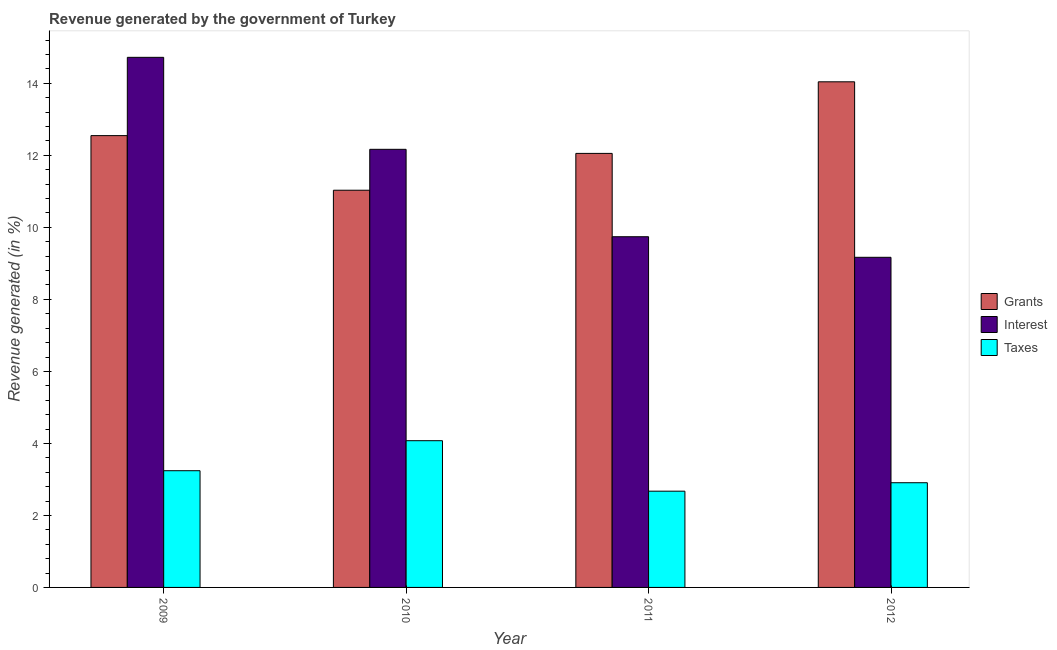How many different coloured bars are there?
Offer a very short reply. 3. How many bars are there on the 1st tick from the right?
Your response must be concise. 3. What is the label of the 3rd group of bars from the left?
Provide a succinct answer. 2011. In how many cases, is the number of bars for a given year not equal to the number of legend labels?
Your answer should be very brief. 0. What is the percentage of revenue generated by taxes in 2009?
Provide a short and direct response. 3.24. Across all years, what is the maximum percentage of revenue generated by interest?
Offer a terse response. 14.72. Across all years, what is the minimum percentage of revenue generated by taxes?
Offer a very short reply. 2.67. In which year was the percentage of revenue generated by interest minimum?
Ensure brevity in your answer.  2012. What is the total percentage of revenue generated by grants in the graph?
Offer a very short reply. 49.68. What is the difference between the percentage of revenue generated by grants in 2009 and that in 2012?
Offer a very short reply. -1.49. What is the difference between the percentage of revenue generated by taxes in 2011 and the percentage of revenue generated by interest in 2009?
Your answer should be very brief. -0.57. What is the average percentage of revenue generated by grants per year?
Your answer should be very brief. 12.42. What is the ratio of the percentage of revenue generated by interest in 2009 to that in 2010?
Provide a succinct answer. 1.21. Is the percentage of revenue generated by interest in 2010 less than that in 2011?
Offer a very short reply. No. What is the difference between the highest and the second highest percentage of revenue generated by grants?
Give a very brief answer. 1.49. What is the difference between the highest and the lowest percentage of revenue generated by grants?
Ensure brevity in your answer.  3.01. In how many years, is the percentage of revenue generated by taxes greater than the average percentage of revenue generated by taxes taken over all years?
Your answer should be very brief. 2. What does the 3rd bar from the left in 2012 represents?
Provide a short and direct response. Taxes. What does the 2nd bar from the right in 2010 represents?
Give a very brief answer. Interest. Is it the case that in every year, the sum of the percentage of revenue generated by grants and percentage of revenue generated by interest is greater than the percentage of revenue generated by taxes?
Offer a terse response. Yes. How many bars are there?
Your answer should be very brief. 12. What is the difference between two consecutive major ticks on the Y-axis?
Give a very brief answer. 2. Does the graph contain grids?
Offer a very short reply. No. Where does the legend appear in the graph?
Offer a very short reply. Center right. How many legend labels are there?
Offer a very short reply. 3. What is the title of the graph?
Make the answer very short. Revenue generated by the government of Turkey. Does "Unemployment benefits" appear as one of the legend labels in the graph?
Provide a short and direct response. No. What is the label or title of the Y-axis?
Keep it short and to the point. Revenue generated (in %). What is the Revenue generated (in %) in Grants in 2009?
Make the answer very short. 12.55. What is the Revenue generated (in %) in Interest in 2009?
Offer a very short reply. 14.72. What is the Revenue generated (in %) of Taxes in 2009?
Offer a very short reply. 3.24. What is the Revenue generated (in %) of Grants in 2010?
Make the answer very short. 11.03. What is the Revenue generated (in %) in Interest in 2010?
Provide a short and direct response. 12.17. What is the Revenue generated (in %) in Taxes in 2010?
Your answer should be very brief. 4.08. What is the Revenue generated (in %) in Grants in 2011?
Ensure brevity in your answer.  12.05. What is the Revenue generated (in %) of Interest in 2011?
Keep it short and to the point. 9.74. What is the Revenue generated (in %) in Taxes in 2011?
Provide a short and direct response. 2.67. What is the Revenue generated (in %) of Grants in 2012?
Offer a very short reply. 14.04. What is the Revenue generated (in %) of Interest in 2012?
Provide a short and direct response. 9.17. What is the Revenue generated (in %) of Taxes in 2012?
Offer a terse response. 2.91. Across all years, what is the maximum Revenue generated (in %) in Grants?
Keep it short and to the point. 14.04. Across all years, what is the maximum Revenue generated (in %) in Interest?
Provide a short and direct response. 14.72. Across all years, what is the maximum Revenue generated (in %) of Taxes?
Provide a succinct answer. 4.08. Across all years, what is the minimum Revenue generated (in %) of Grants?
Provide a succinct answer. 11.03. Across all years, what is the minimum Revenue generated (in %) of Interest?
Give a very brief answer. 9.17. Across all years, what is the minimum Revenue generated (in %) in Taxes?
Your answer should be very brief. 2.67. What is the total Revenue generated (in %) of Grants in the graph?
Ensure brevity in your answer.  49.68. What is the total Revenue generated (in %) of Interest in the graph?
Give a very brief answer. 45.8. What is the total Revenue generated (in %) in Taxes in the graph?
Provide a succinct answer. 12.9. What is the difference between the Revenue generated (in %) in Grants in 2009 and that in 2010?
Make the answer very short. 1.52. What is the difference between the Revenue generated (in %) of Interest in 2009 and that in 2010?
Offer a very short reply. 2.56. What is the difference between the Revenue generated (in %) of Taxes in 2009 and that in 2010?
Ensure brevity in your answer.  -0.83. What is the difference between the Revenue generated (in %) of Grants in 2009 and that in 2011?
Ensure brevity in your answer.  0.49. What is the difference between the Revenue generated (in %) of Interest in 2009 and that in 2011?
Offer a terse response. 4.98. What is the difference between the Revenue generated (in %) of Taxes in 2009 and that in 2011?
Keep it short and to the point. 0.57. What is the difference between the Revenue generated (in %) of Grants in 2009 and that in 2012?
Your answer should be very brief. -1.49. What is the difference between the Revenue generated (in %) of Interest in 2009 and that in 2012?
Provide a succinct answer. 5.55. What is the difference between the Revenue generated (in %) in Taxes in 2009 and that in 2012?
Ensure brevity in your answer.  0.33. What is the difference between the Revenue generated (in %) of Grants in 2010 and that in 2011?
Your answer should be compact. -1.02. What is the difference between the Revenue generated (in %) of Interest in 2010 and that in 2011?
Keep it short and to the point. 2.43. What is the difference between the Revenue generated (in %) of Taxes in 2010 and that in 2011?
Offer a very short reply. 1.4. What is the difference between the Revenue generated (in %) in Grants in 2010 and that in 2012?
Your response must be concise. -3.01. What is the difference between the Revenue generated (in %) in Interest in 2010 and that in 2012?
Offer a very short reply. 3. What is the difference between the Revenue generated (in %) of Taxes in 2010 and that in 2012?
Keep it short and to the point. 1.17. What is the difference between the Revenue generated (in %) of Grants in 2011 and that in 2012?
Offer a terse response. -1.99. What is the difference between the Revenue generated (in %) of Interest in 2011 and that in 2012?
Your answer should be compact. 0.57. What is the difference between the Revenue generated (in %) of Taxes in 2011 and that in 2012?
Keep it short and to the point. -0.23. What is the difference between the Revenue generated (in %) of Grants in 2009 and the Revenue generated (in %) of Interest in 2010?
Your answer should be very brief. 0.38. What is the difference between the Revenue generated (in %) in Grants in 2009 and the Revenue generated (in %) in Taxes in 2010?
Offer a very short reply. 8.47. What is the difference between the Revenue generated (in %) in Interest in 2009 and the Revenue generated (in %) in Taxes in 2010?
Offer a very short reply. 10.65. What is the difference between the Revenue generated (in %) of Grants in 2009 and the Revenue generated (in %) of Interest in 2011?
Keep it short and to the point. 2.81. What is the difference between the Revenue generated (in %) of Grants in 2009 and the Revenue generated (in %) of Taxes in 2011?
Ensure brevity in your answer.  9.88. What is the difference between the Revenue generated (in %) in Interest in 2009 and the Revenue generated (in %) in Taxes in 2011?
Your answer should be compact. 12.05. What is the difference between the Revenue generated (in %) in Grants in 2009 and the Revenue generated (in %) in Interest in 2012?
Ensure brevity in your answer.  3.38. What is the difference between the Revenue generated (in %) in Grants in 2009 and the Revenue generated (in %) in Taxes in 2012?
Provide a succinct answer. 9.64. What is the difference between the Revenue generated (in %) of Interest in 2009 and the Revenue generated (in %) of Taxes in 2012?
Your response must be concise. 11.82. What is the difference between the Revenue generated (in %) in Grants in 2010 and the Revenue generated (in %) in Interest in 2011?
Give a very brief answer. 1.29. What is the difference between the Revenue generated (in %) of Grants in 2010 and the Revenue generated (in %) of Taxes in 2011?
Keep it short and to the point. 8.36. What is the difference between the Revenue generated (in %) in Interest in 2010 and the Revenue generated (in %) in Taxes in 2011?
Offer a terse response. 9.5. What is the difference between the Revenue generated (in %) of Grants in 2010 and the Revenue generated (in %) of Interest in 2012?
Offer a very short reply. 1.86. What is the difference between the Revenue generated (in %) of Grants in 2010 and the Revenue generated (in %) of Taxes in 2012?
Your answer should be compact. 8.12. What is the difference between the Revenue generated (in %) of Interest in 2010 and the Revenue generated (in %) of Taxes in 2012?
Your answer should be very brief. 9.26. What is the difference between the Revenue generated (in %) in Grants in 2011 and the Revenue generated (in %) in Interest in 2012?
Provide a succinct answer. 2.89. What is the difference between the Revenue generated (in %) of Grants in 2011 and the Revenue generated (in %) of Taxes in 2012?
Offer a very short reply. 9.15. What is the difference between the Revenue generated (in %) in Interest in 2011 and the Revenue generated (in %) in Taxes in 2012?
Ensure brevity in your answer.  6.83. What is the average Revenue generated (in %) of Grants per year?
Give a very brief answer. 12.42. What is the average Revenue generated (in %) in Interest per year?
Offer a very short reply. 11.45. What is the average Revenue generated (in %) in Taxes per year?
Make the answer very short. 3.22. In the year 2009, what is the difference between the Revenue generated (in %) in Grants and Revenue generated (in %) in Interest?
Give a very brief answer. -2.17. In the year 2009, what is the difference between the Revenue generated (in %) of Grants and Revenue generated (in %) of Taxes?
Make the answer very short. 9.31. In the year 2009, what is the difference between the Revenue generated (in %) of Interest and Revenue generated (in %) of Taxes?
Offer a very short reply. 11.48. In the year 2010, what is the difference between the Revenue generated (in %) in Grants and Revenue generated (in %) in Interest?
Provide a succinct answer. -1.14. In the year 2010, what is the difference between the Revenue generated (in %) in Grants and Revenue generated (in %) in Taxes?
Provide a short and direct response. 6.96. In the year 2010, what is the difference between the Revenue generated (in %) of Interest and Revenue generated (in %) of Taxes?
Keep it short and to the point. 8.09. In the year 2011, what is the difference between the Revenue generated (in %) in Grants and Revenue generated (in %) in Interest?
Keep it short and to the point. 2.31. In the year 2011, what is the difference between the Revenue generated (in %) in Grants and Revenue generated (in %) in Taxes?
Keep it short and to the point. 9.38. In the year 2011, what is the difference between the Revenue generated (in %) in Interest and Revenue generated (in %) in Taxes?
Provide a short and direct response. 7.07. In the year 2012, what is the difference between the Revenue generated (in %) in Grants and Revenue generated (in %) in Interest?
Give a very brief answer. 4.87. In the year 2012, what is the difference between the Revenue generated (in %) of Grants and Revenue generated (in %) of Taxes?
Offer a very short reply. 11.14. In the year 2012, what is the difference between the Revenue generated (in %) in Interest and Revenue generated (in %) in Taxes?
Keep it short and to the point. 6.26. What is the ratio of the Revenue generated (in %) in Grants in 2009 to that in 2010?
Your answer should be compact. 1.14. What is the ratio of the Revenue generated (in %) of Interest in 2009 to that in 2010?
Make the answer very short. 1.21. What is the ratio of the Revenue generated (in %) of Taxes in 2009 to that in 2010?
Keep it short and to the point. 0.8. What is the ratio of the Revenue generated (in %) of Grants in 2009 to that in 2011?
Keep it short and to the point. 1.04. What is the ratio of the Revenue generated (in %) of Interest in 2009 to that in 2011?
Provide a short and direct response. 1.51. What is the ratio of the Revenue generated (in %) of Taxes in 2009 to that in 2011?
Keep it short and to the point. 1.21. What is the ratio of the Revenue generated (in %) of Grants in 2009 to that in 2012?
Offer a terse response. 0.89. What is the ratio of the Revenue generated (in %) in Interest in 2009 to that in 2012?
Your answer should be very brief. 1.61. What is the ratio of the Revenue generated (in %) of Taxes in 2009 to that in 2012?
Give a very brief answer. 1.11. What is the ratio of the Revenue generated (in %) in Grants in 2010 to that in 2011?
Provide a short and direct response. 0.92. What is the ratio of the Revenue generated (in %) in Interest in 2010 to that in 2011?
Give a very brief answer. 1.25. What is the ratio of the Revenue generated (in %) of Taxes in 2010 to that in 2011?
Provide a short and direct response. 1.52. What is the ratio of the Revenue generated (in %) in Grants in 2010 to that in 2012?
Your response must be concise. 0.79. What is the ratio of the Revenue generated (in %) of Interest in 2010 to that in 2012?
Offer a very short reply. 1.33. What is the ratio of the Revenue generated (in %) in Taxes in 2010 to that in 2012?
Offer a terse response. 1.4. What is the ratio of the Revenue generated (in %) of Grants in 2011 to that in 2012?
Provide a short and direct response. 0.86. What is the ratio of the Revenue generated (in %) of Interest in 2011 to that in 2012?
Ensure brevity in your answer.  1.06. What is the ratio of the Revenue generated (in %) in Taxes in 2011 to that in 2012?
Make the answer very short. 0.92. What is the difference between the highest and the second highest Revenue generated (in %) of Grants?
Your answer should be very brief. 1.49. What is the difference between the highest and the second highest Revenue generated (in %) of Interest?
Offer a terse response. 2.56. What is the difference between the highest and the second highest Revenue generated (in %) in Taxes?
Give a very brief answer. 0.83. What is the difference between the highest and the lowest Revenue generated (in %) of Grants?
Your answer should be very brief. 3.01. What is the difference between the highest and the lowest Revenue generated (in %) of Interest?
Make the answer very short. 5.55. What is the difference between the highest and the lowest Revenue generated (in %) of Taxes?
Keep it short and to the point. 1.4. 